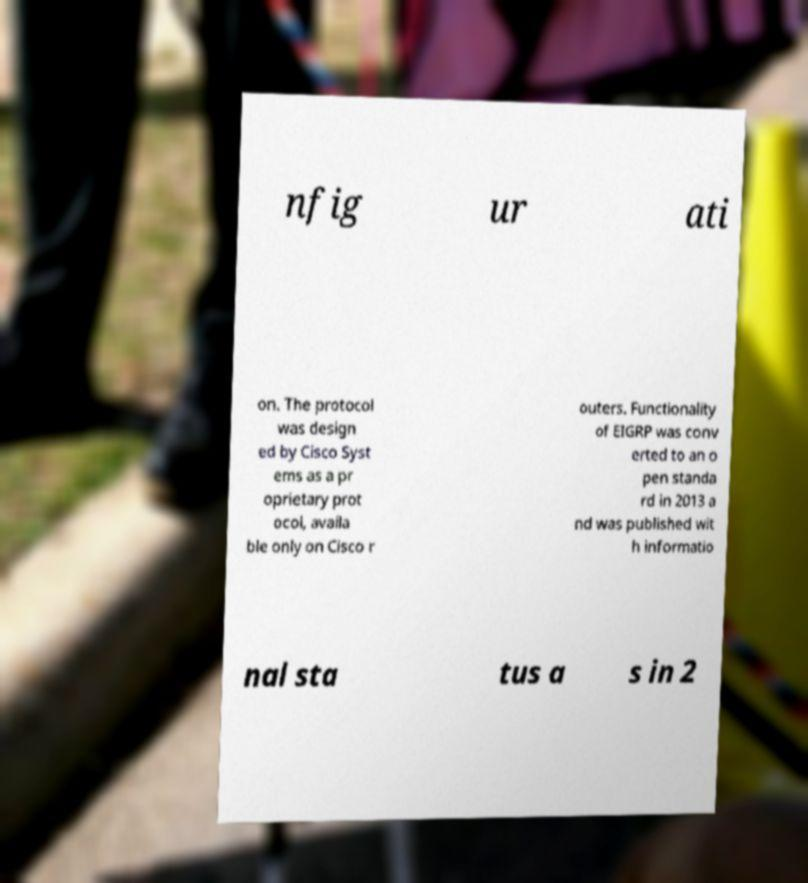Could you extract and type out the text from this image? nfig ur ati on. The protocol was design ed by Cisco Syst ems as a pr oprietary prot ocol, availa ble only on Cisco r outers. Functionality of EIGRP was conv erted to an o pen standa rd in 2013 a nd was published wit h informatio nal sta tus a s in 2 